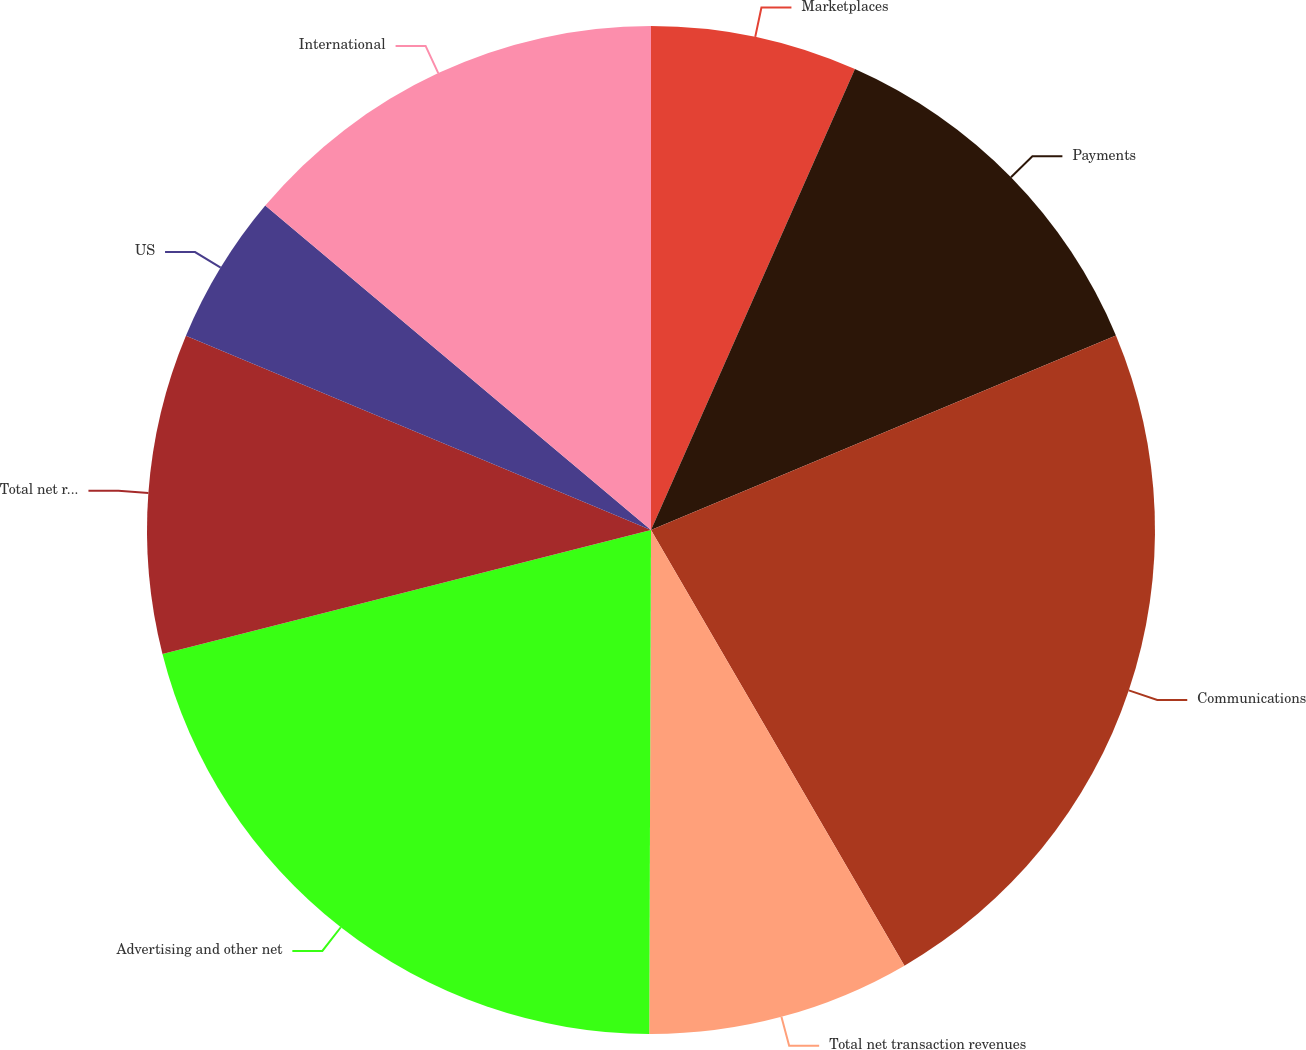<chart> <loc_0><loc_0><loc_500><loc_500><pie_chart><fcel>Marketplaces<fcel>Payments<fcel>Communications<fcel>Total net transaction revenues<fcel>Advertising and other net<fcel>Total net revenues<fcel>US<fcel>International<nl><fcel>6.63%<fcel>12.06%<fcel>22.92%<fcel>8.44%<fcel>20.99%<fcel>10.25%<fcel>4.83%<fcel>13.87%<nl></chart> 